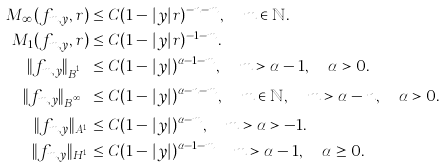<formula> <loc_0><loc_0><loc_500><loc_500>M _ { \infty } ( f _ { m , y } , r ) & \leq C ( 1 - | y | r ) ^ { - n - m } , \quad m \in \mathbb { N } . \\ M _ { 1 } ( f _ { m , y } , r ) & \leq C ( 1 - | y | r ) ^ { - 1 - m } . \\ \| f _ { m , y } \| _ { B ^ { p , 1 } _ { \alpha } } & \leq C ( 1 - | y | ) ^ { \alpha - 1 - m } , \quad m > \alpha - 1 , \quad \alpha > 0 . \\ \| f _ { m , y } \| _ { B ^ { p , \infty } _ { \alpha } } & \leq C ( 1 - | y | ) ^ { \alpha - n - m } , \quad m \in \mathbb { N } , \quad m > \alpha - n , \quad \alpha > 0 . \\ \| f _ { m , y } \| _ { A ^ { 1 } _ { \alpha } } & \leq C ( 1 - | y | ) ^ { \alpha - m } , \quad m > \alpha > - 1 . \\ \| f _ { m , y } \| _ { H ^ { 1 } _ { \alpha } } & \leq C ( 1 - | y | ) ^ { \alpha - 1 - m } \quad m > \alpha - 1 , \quad \alpha \geq 0 .</formula> 